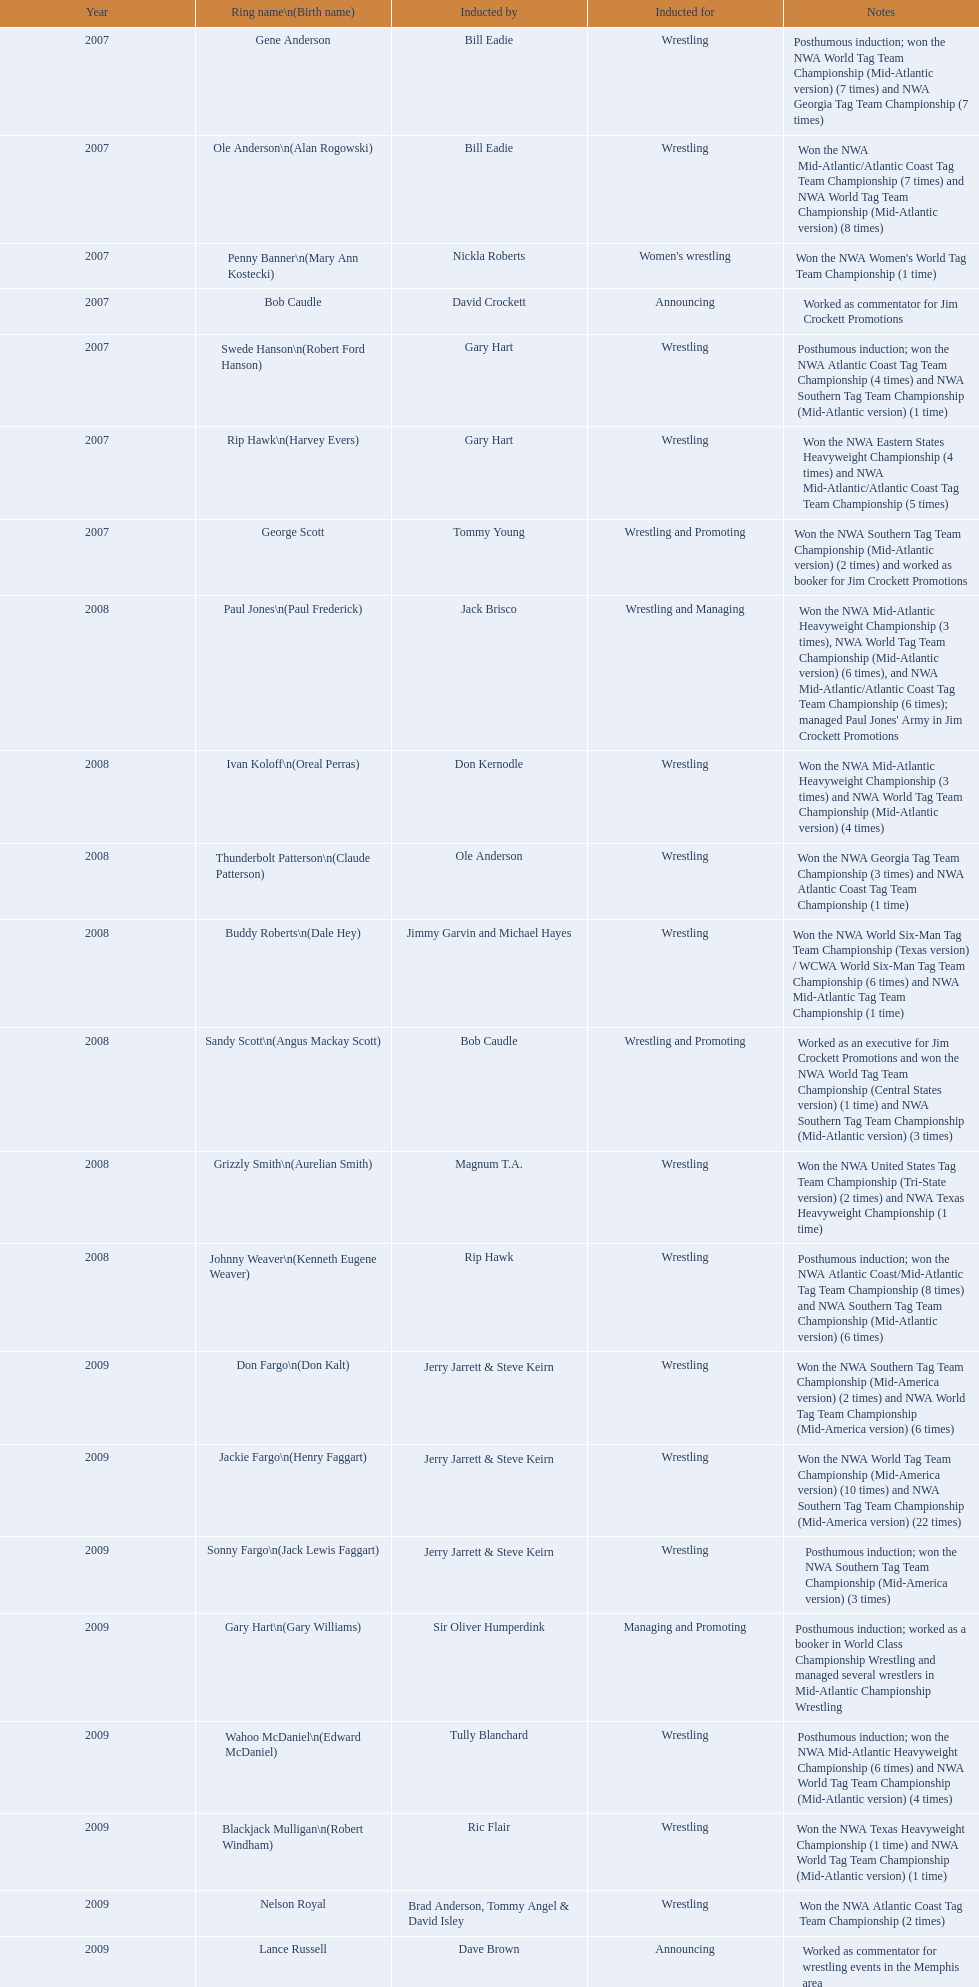Who are the inducted announcers? Bob Caudle, Lance Russell. In 2009, which announcer was inducted? Lance Russell. 